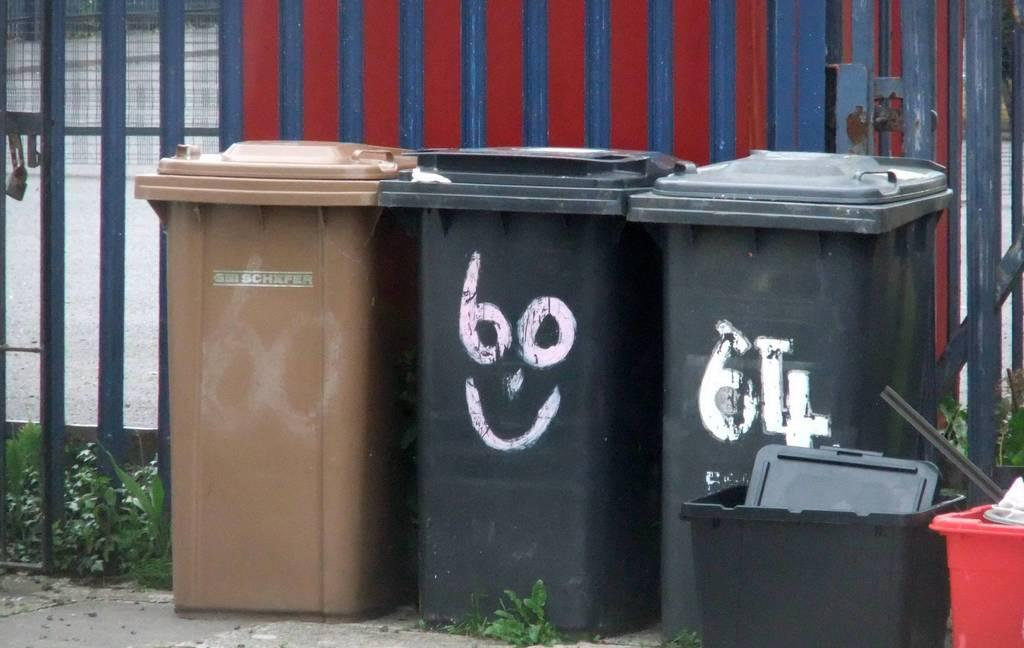<image>
Offer a succinct explanation of the picture presented. Three trash receptacles, 2 black and 1 brown. 